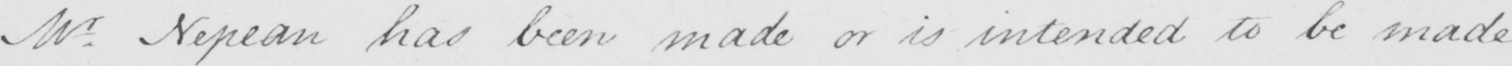Can you read and transcribe this handwriting? Mr Nepean has been made or is intended to be made. . 